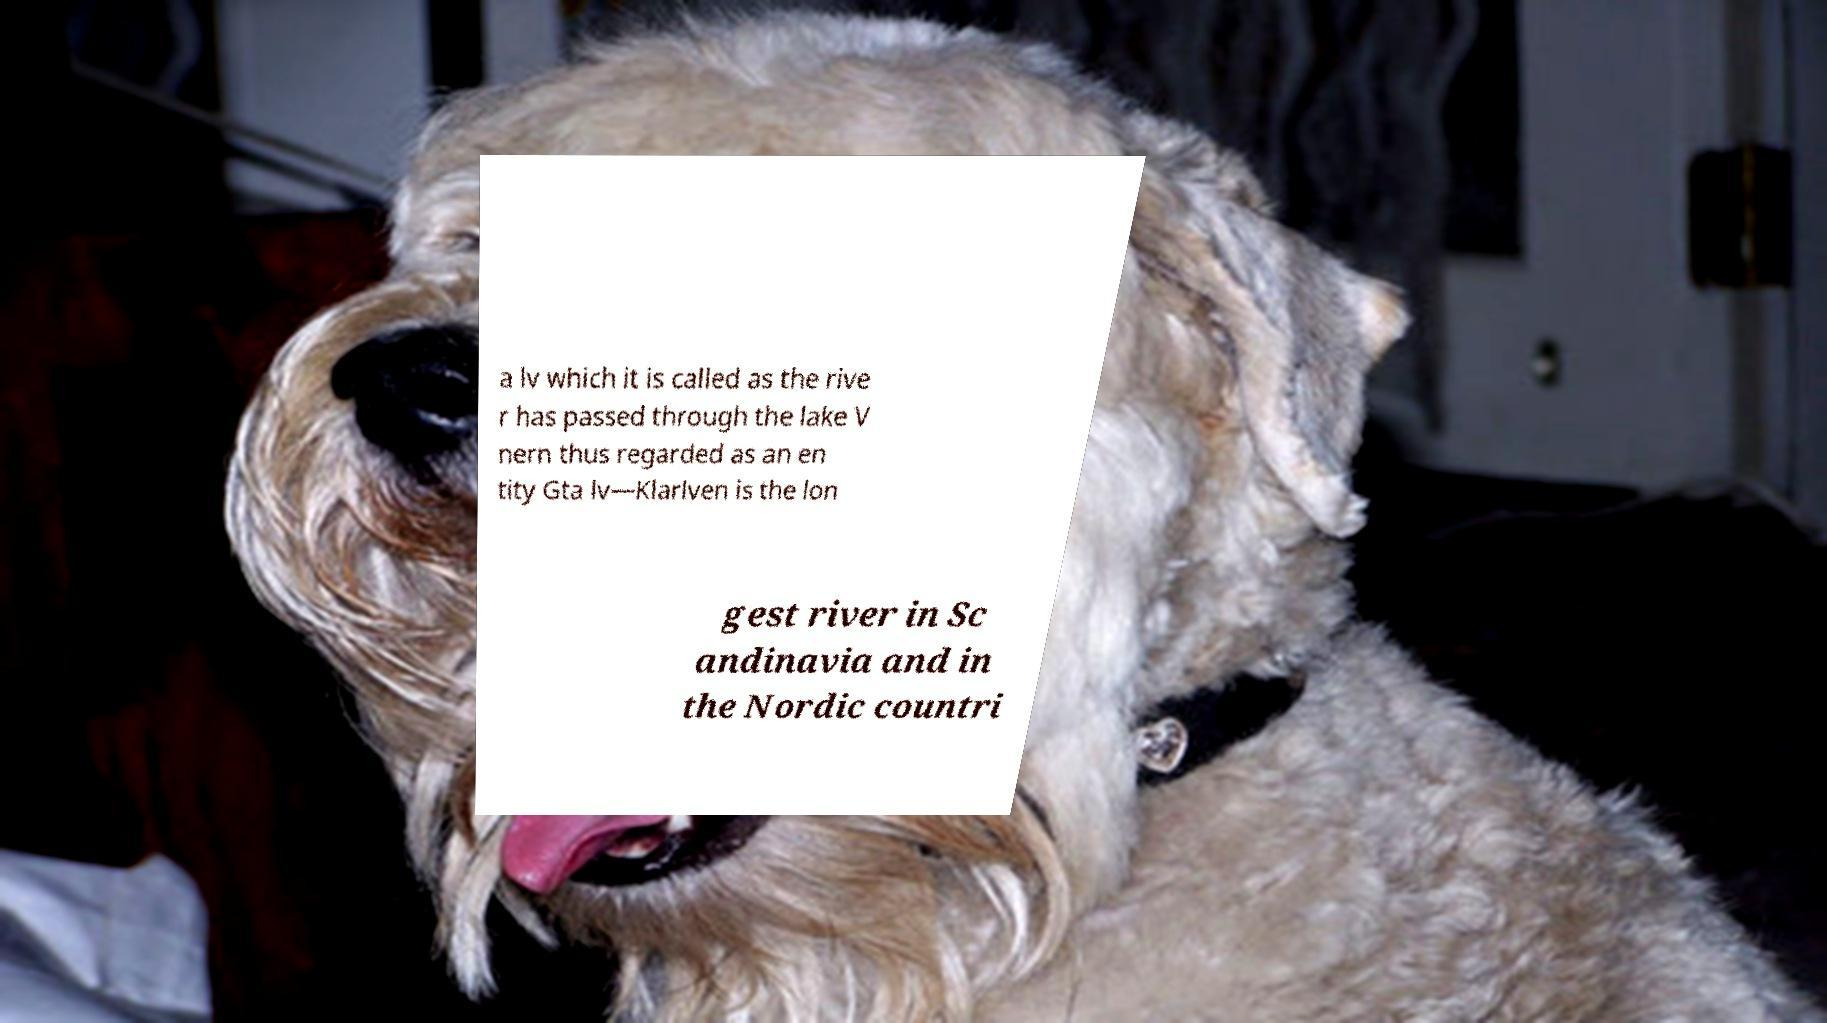Could you assist in decoding the text presented in this image and type it out clearly? a lv which it is called as the rive r has passed through the lake V nern thus regarded as an en tity Gta lv—Klarlven is the lon gest river in Sc andinavia and in the Nordic countri 